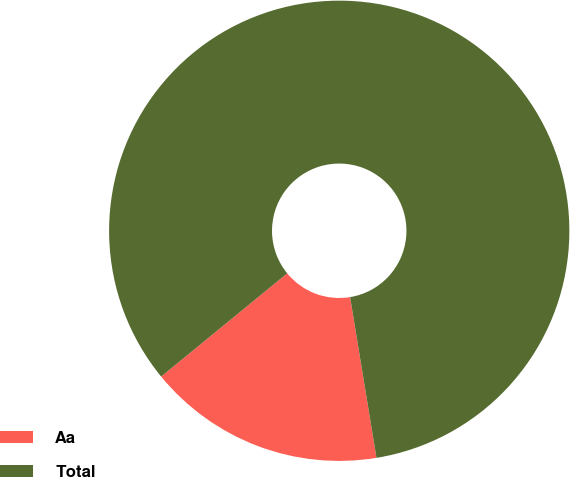Convert chart. <chart><loc_0><loc_0><loc_500><loc_500><pie_chart><fcel>Aa<fcel>Total<nl><fcel>16.67%<fcel>83.33%<nl></chart> 